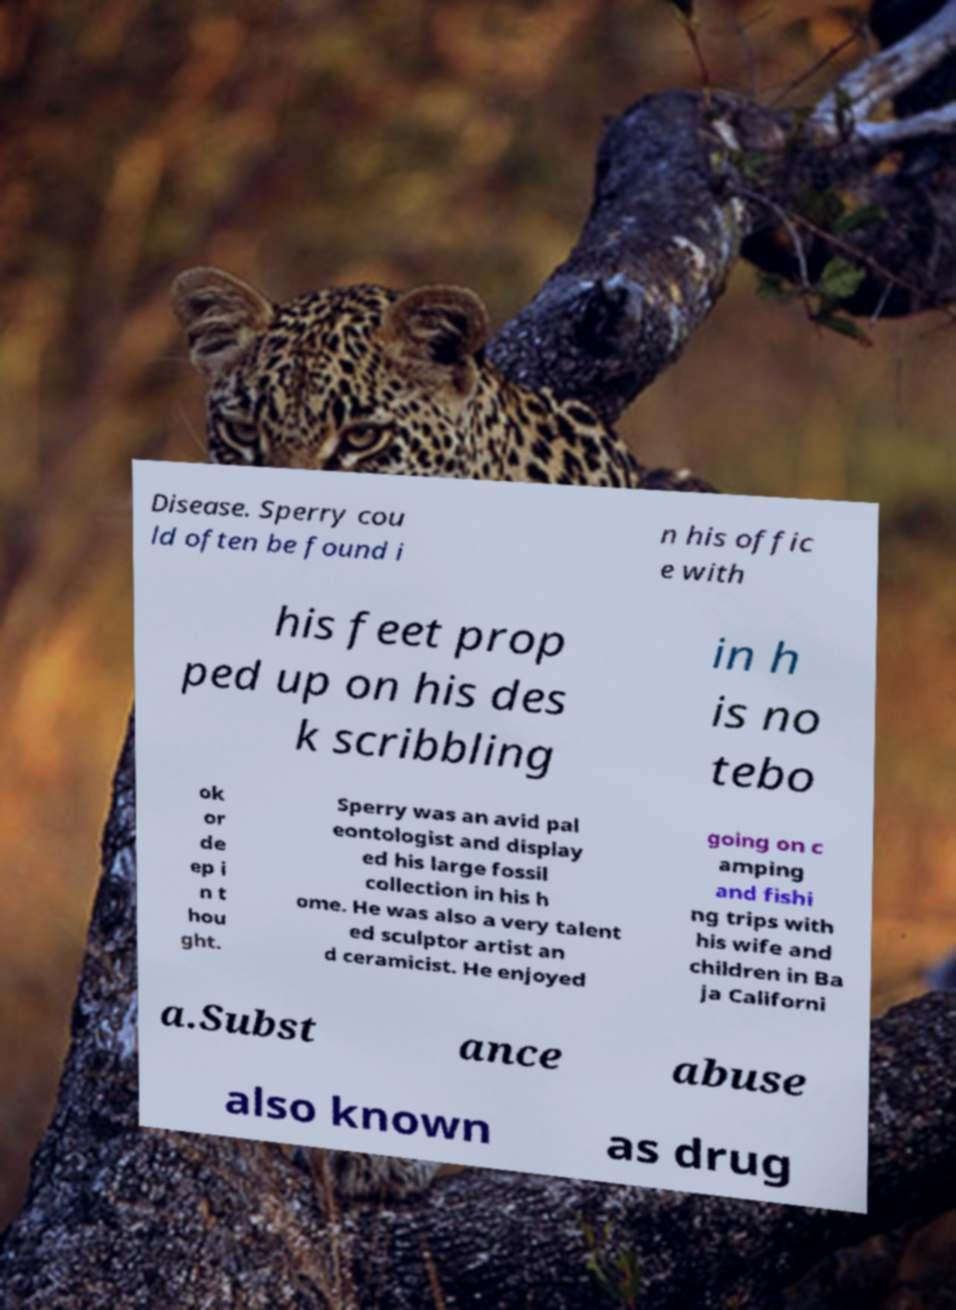I need the written content from this picture converted into text. Can you do that? Disease. Sperry cou ld often be found i n his offic e with his feet prop ped up on his des k scribbling in h is no tebo ok or de ep i n t hou ght. Sperry was an avid pal eontologist and display ed his large fossil collection in his h ome. He was also a very talent ed sculptor artist an d ceramicist. He enjoyed going on c amping and fishi ng trips with his wife and children in Ba ja Californi a.Subst ance abuse also known as drug 